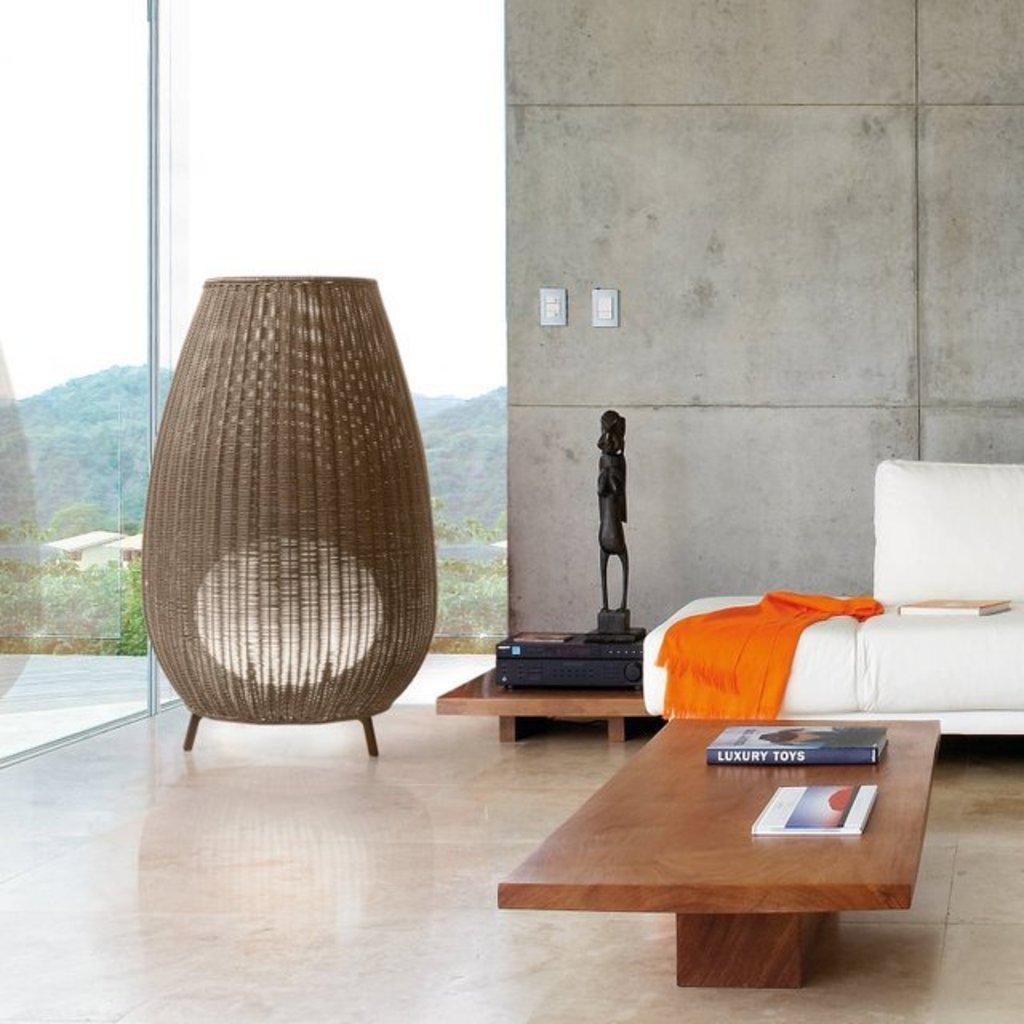Describe this image in one or two sentences. In the image we can see there is a table on which there are books and on sofa there is a cloth and a book kept. 